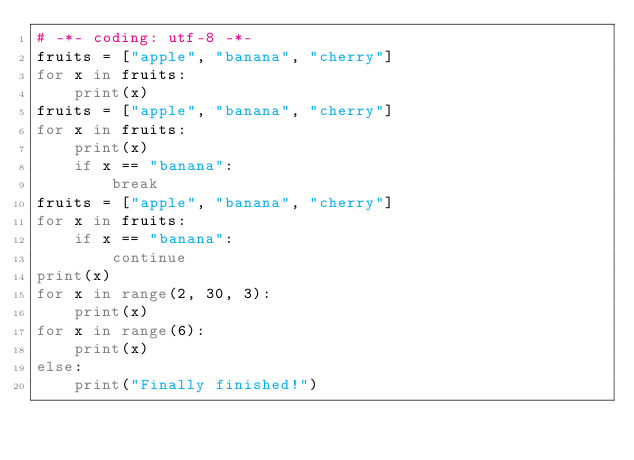<code> <loc_0><loc_0><loc_500><loc_500><_Python_># -*- coding: utf-8 -*-
fruits = ["apple", "banana", "cherry"]
for x in fruits:
    print(x)
fruits = ["apple", "banana", "cherry"]
for x in fruits:
    print(x)
    if x == "banana":
        break
fruits = ["apple", "banana", "cherry"]
for x in fruits:
    if x == "banana":
        continue
print(x)
for x in range(2, 30, 3):
    print(x)
for x in range(6):
    print(x)
else:
    print("Finally finished!")

</code> 